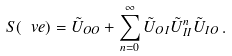Convert formula to latex. <formula><loc_0><loc_0><loc_500><loc_500>S ( \ v e ) = \tilde { U } _ { O O } + \sum _ { n = 0 } ^ { \infty } \tilde { U } _ { O I } \tilde { U } _ { I I } ^ { n } \tilde { U } _ { I O } \, .</formula> 